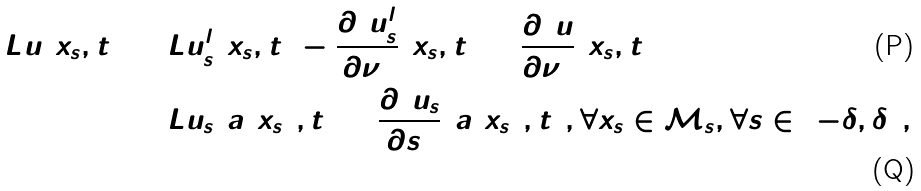Convert formula to latex. <formula><loc_0><loc_0><loc_500><loc_500>\hat { L } \hat { u } ( x _ { s } , t ) & = \hat { L } \tilde { u } ^ { l } _ { s } ( x _ { s } , t ) - \frac { \partial ^ { 2 } \tilde { u } ^ { l } _ { s } } { \partial \nu ^ { 2 } } ( x _ { s } , t ) + \frac { \partial ^ { 2 } \hat { u } } { \partial \nu ^ { 2 } } ( x _ { s } , t ) \\ & = L \tilde { u } _ { s } ( a ( x _ { s } ) , t ) + \frac { \partial ^ { 2 } \tilde { u } _ { s } } { \partial s ^ { 2 } } ( a ( x _ { s } ) , t ) , \forall x _ { s } \in \mathcal { M } _ { s } , \forall s \in ( - \delta , \delta ) ,</formula> 